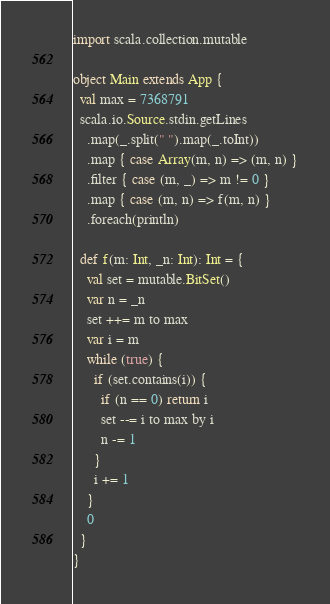<code> <loc_0><loc_0><loc_500><loc_500><_Scala_>import scala.collection.mutable

object Main extends App {
  val max = 7368791
  scala.io.Source.stdin.getLines
    .map(_.split(" ").map(_.toInt))
    .map { case Array(m, n) => (m, n) }
    .filter { case (m, _) => m != 0 }
    .map { case (m, n) => f(m, n) }
    .foreach(println)

  def f(m: Int, _n: Int): Int = {
    val set = mutable.BitSet()
    var n = _n
    set ++= m to max
    var i = m
    while (true) {
      if (set.contains(i)) {
        if (n == 0) return i
        set --= i to max by i
        n -= 1
      }
      i += 1
    }
    0
  }
}

</code> 